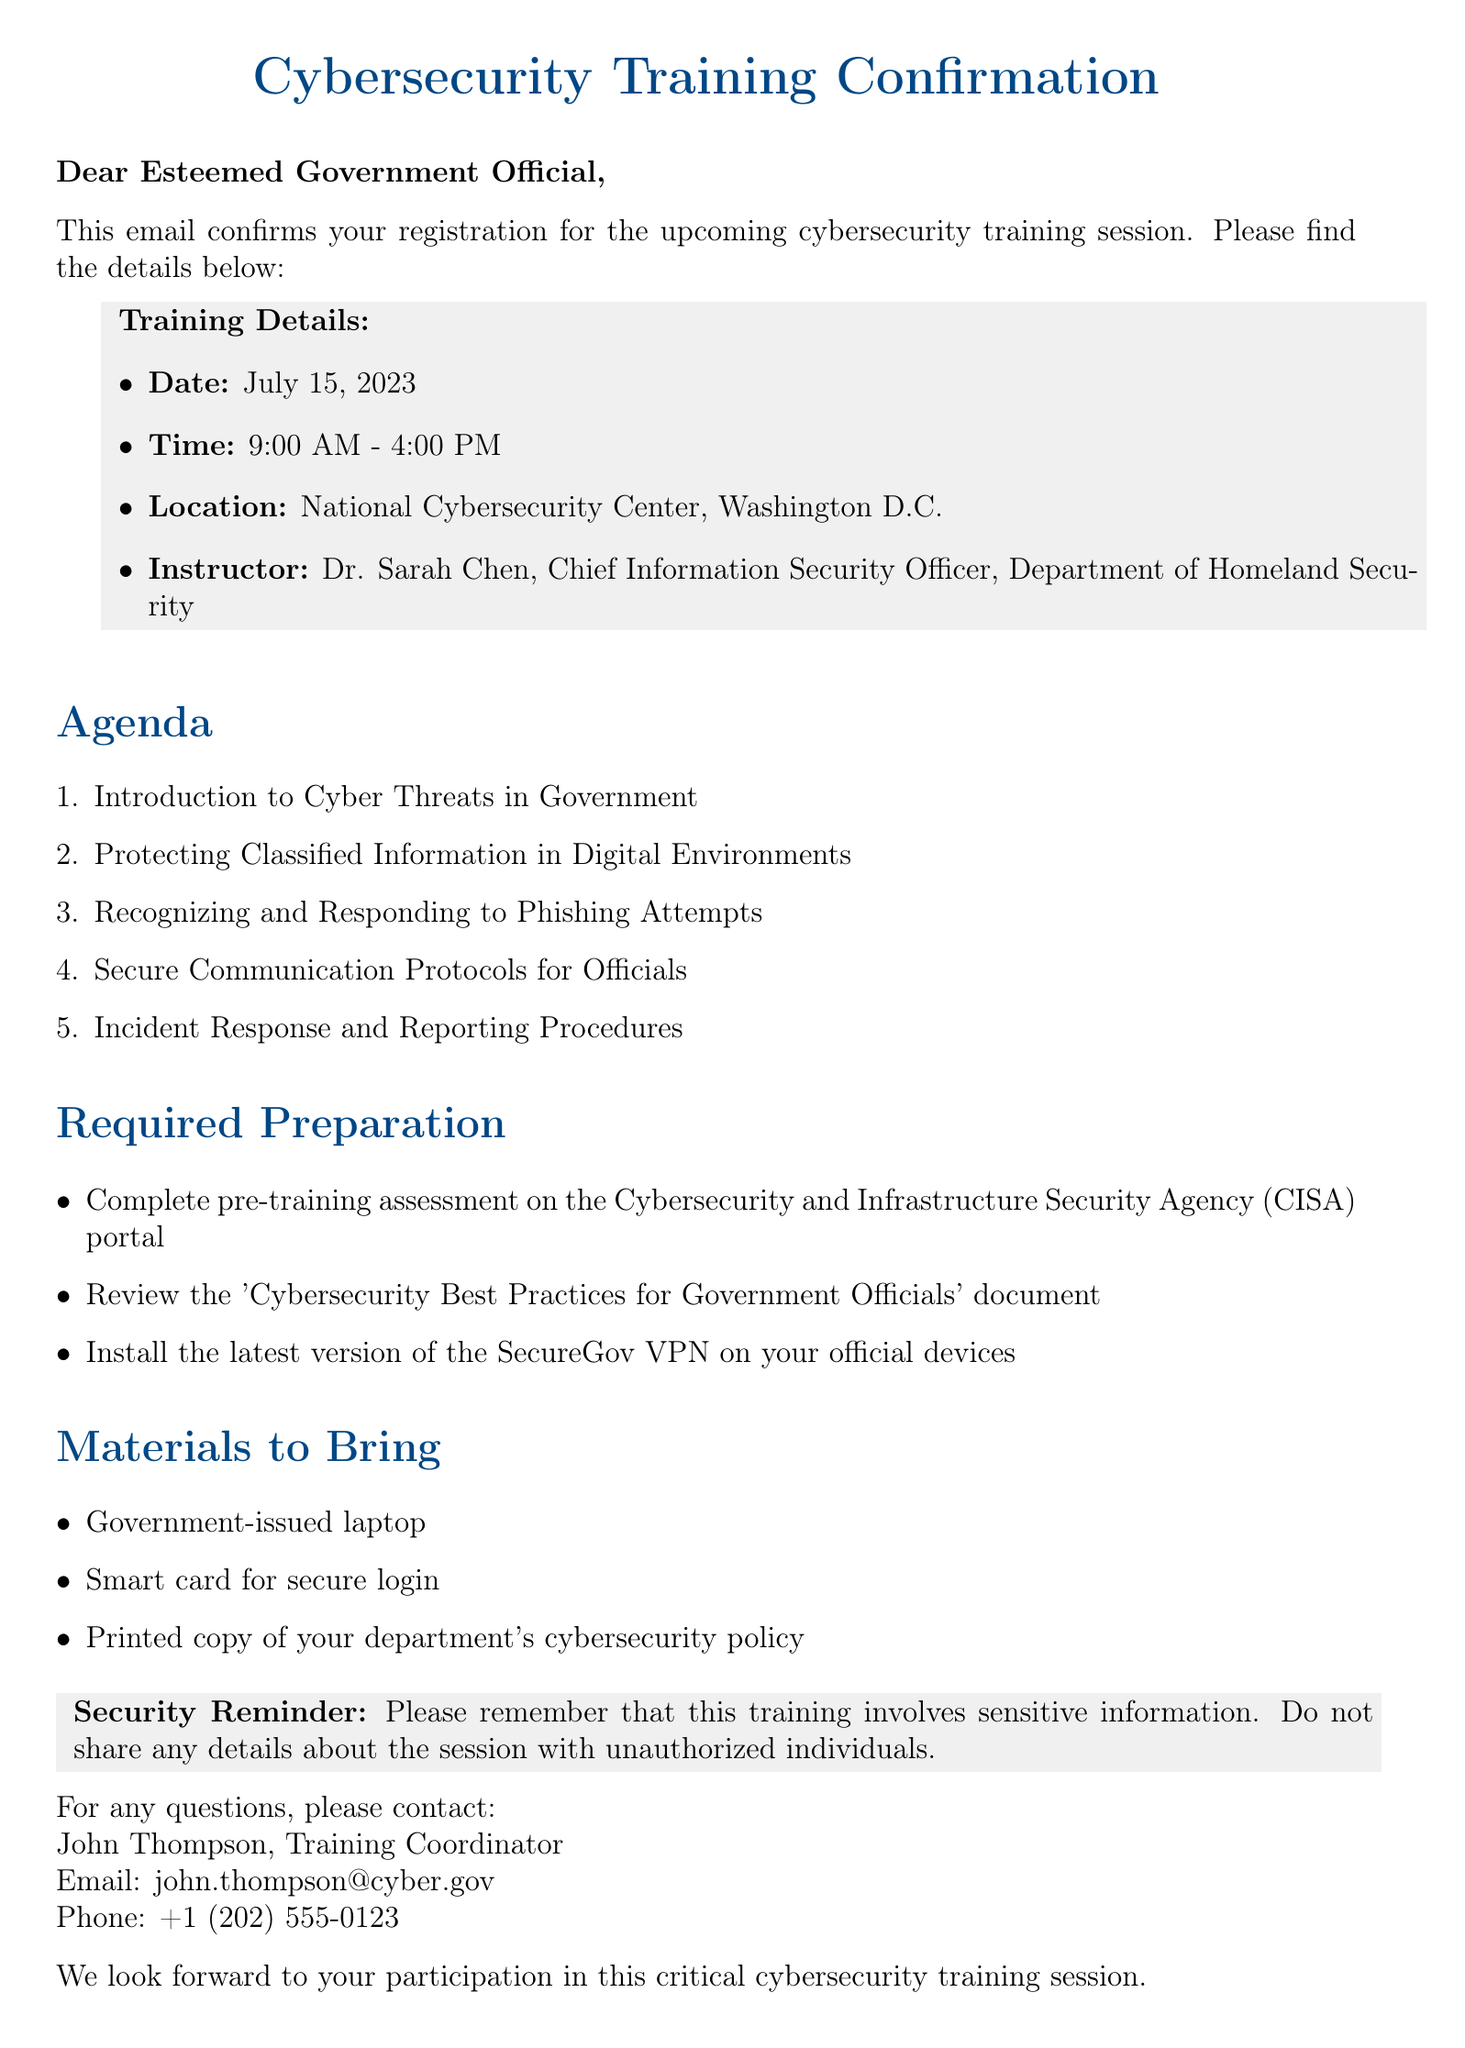What is the training date? The training date is explicitly mentioned in the document under training details.
Answer: July 15, 2023 Who is the instructor for the training session? The instructor's name and title are provided in the training details section of the document.
Answer: Dr. Sarah Chen What is the duration of the training session? The document states the time frame of the training, which allows calculating its duration.
Answer: 7 hours Where is the training location? The location is directly specified in the training details section of the document.
Answer: National Cybersecurity Center, Washington D.C What is one of the materials that must be brought? The document lists specific materials that participants are required to bring to the training session.
Answer: Government-issued laptop What should participants complete prior to the training? The required preparation section provides specific actions that must be taken before the training.
Answer: Pre-training assessment on the CISA portal What is the purpose of this email? The primary purpose of the email is stated at the beginning, confirming registration and providing details about the training.
Answer: Confirmation of registration for the training session Who should be contacted for questions? The document provides contact information for inquiries, specifying the contact person and their role.
Answer: John Thompson Why is there a security reminder included? The reminder highlights the sensitivity of the information shared during the training, as noted in the document.
Answer: Sensitive information protection 